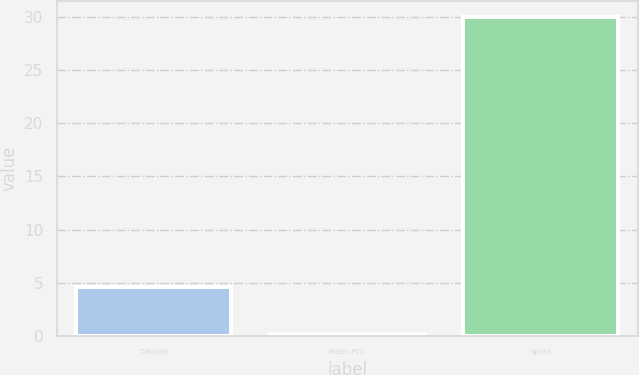Convert chart to OTSL. <chart><loc_0><loc_0><loc_500><loc_500><bar_chart><fcel>T-Mobile<fcel>Metro PCS<fcel>Sprint<nl><fcel>4.6<fcel>0.2<fcel>30<nl></chart> 